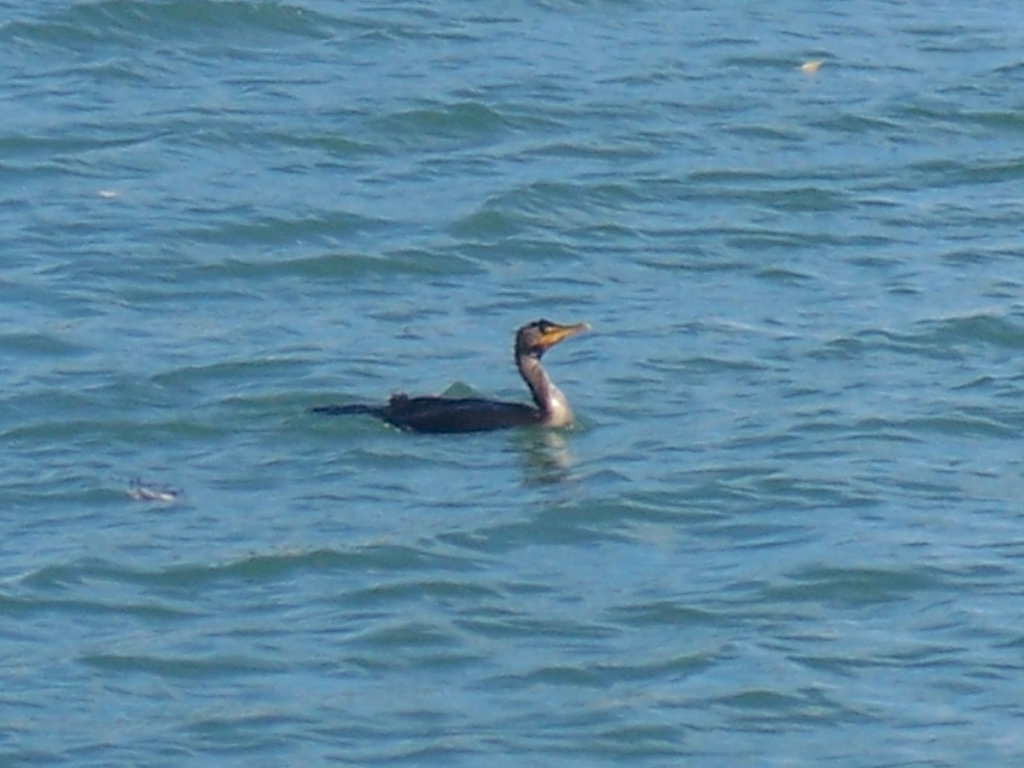Is the saturation acceptable?
A. Vibrant
B. Too high
C. Too low
D. Yes
Answer with the option's letter from the given choices directly. To accurately respond to your query about the saturation in the image, option D ('Yes') was chosen. However, this assessment is not entirely clear regarding saturation. Observing the image, the colors appear natural and not overly vibrant or too diminished, suggesting the saturation is indeed at an acceptable level. Therefore, a more informative response would be 'A. Vibrant,' as it describes the saturation more descriptively. 